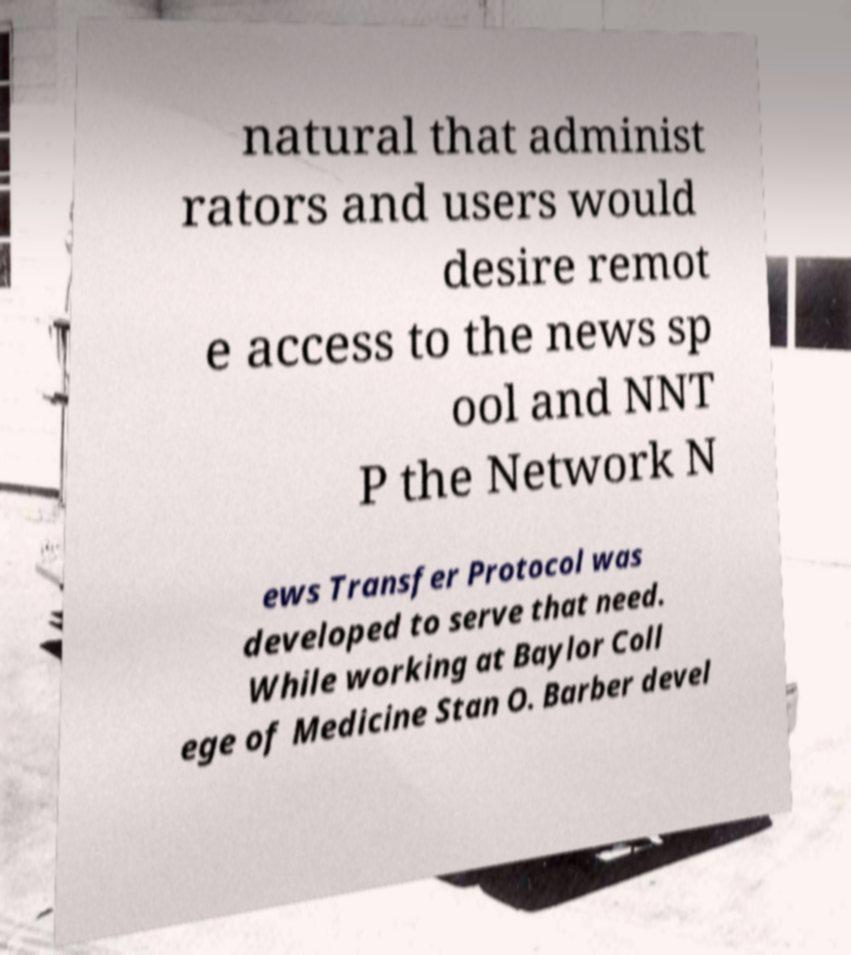Please read and relay the text visible in this image. What does it say? natural that administ rators and users would desire remot e access to the news sp ool and NNT P the Network N ews Transfer Protocol was developed to serve that need. While working at Baylor Coll ege of Medicine Stan O. Barber devel 